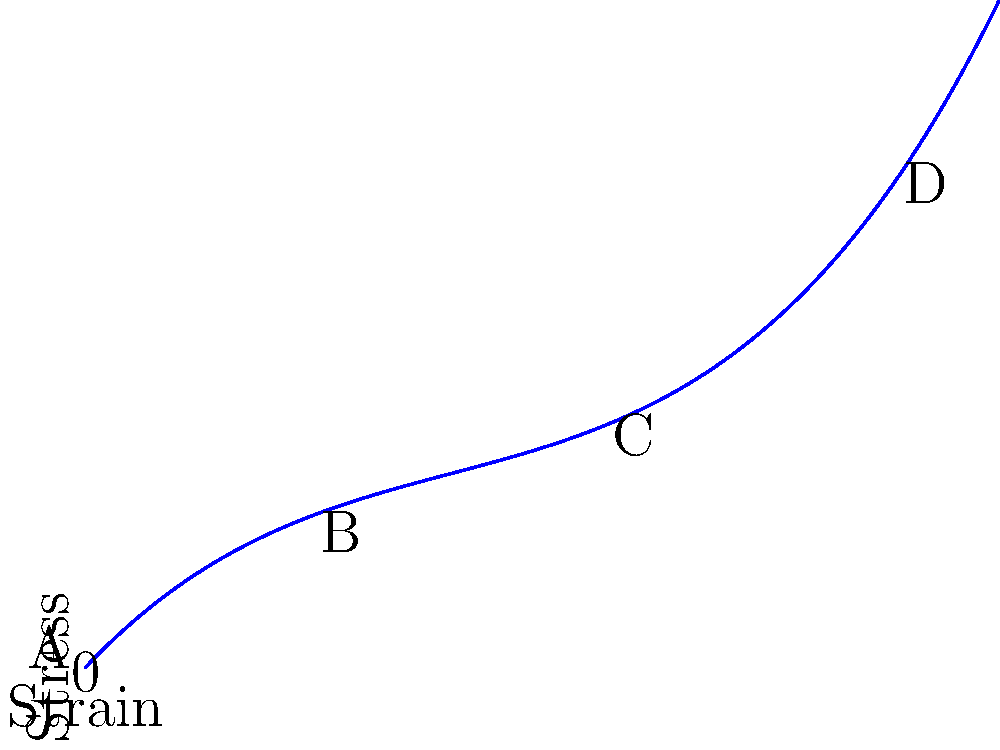In the stress-strain curve for a tendon shown above, which region represents the linear elastic phase where Hooke's law applies, and what does this imply about the tendon's behavior in this phase? To answer this question, let's analyze the stress-strain curve:

1. The curve can be divided into four main regions:
   A: Initial concave-up region (toe region)
   B: Linear region
   C: Yield region
   D: Failure region

2. The linear elastic phase, where Hooke's law applies, is represented by region B.

3. In this linear region:
   - The relationship between stress and strain is directly proportional.
   - This is described by Hooke's law: $\sigma = E\epsilon$, where $\sigma$ is stress, $E$ is Young's modulus, and $\epsilon$ is strain.

4. The linear relationship implies:
   - The tendon deforms elastically, meaning it will return to its original shape when the stress is removed.
   - The slope of this line represents the Young's modulus (E), which is a measure of the tendon's stiffness.

5. Implications for tendon behavior in this phase:
   - Predictable and consistent mechanical response
   - No permanent deformation occurs
   - Energy storage and return is efficient and proportional to the applied load

6. It's important to note that this linear region represents the tendon's physiological working range under normal conditions.
Answer: Region B; tendon deforms elastically and returns to original shape when stress is removed. 